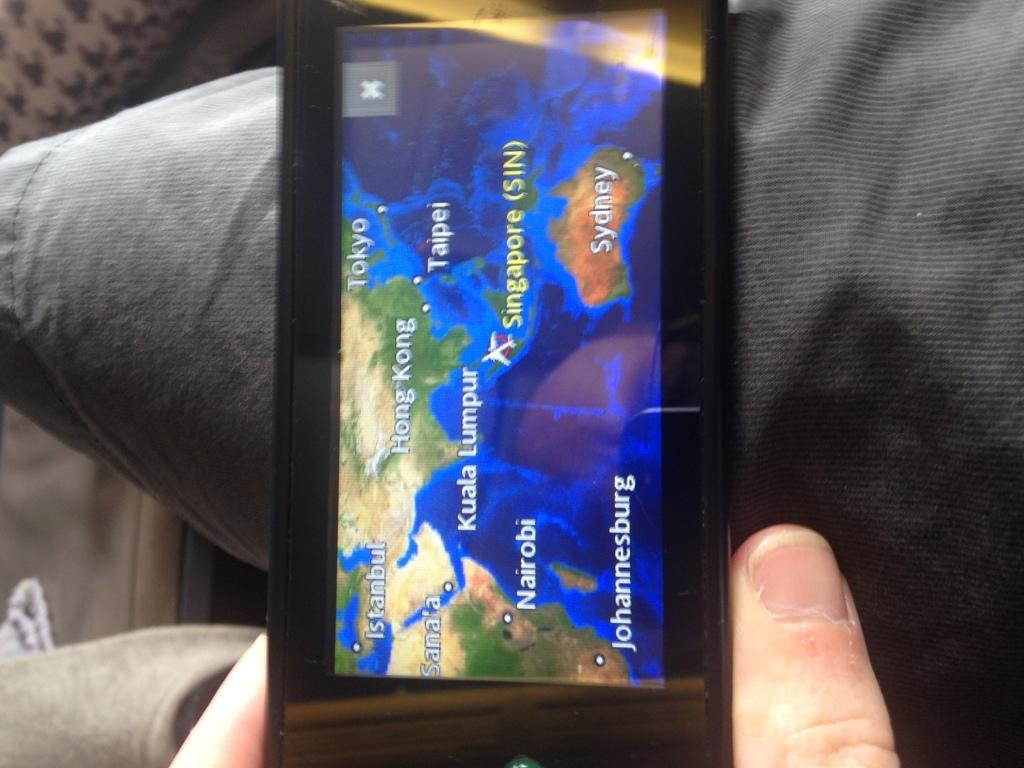Provide a one-sentence caption for the provided image. A person is holding a gps showing a map of Hong Kong. 